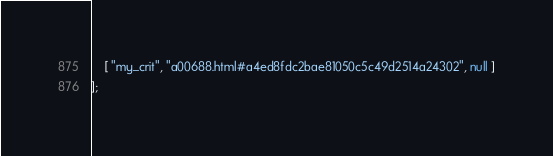Convert code to text. <code><loc_0><loc_0><loc_500><loc_500><_JavaScript_>    [ "my_crit", "a00688.html#a4ed8fdc2bae81050c5c49d2514a24302", null ]
];</code> 